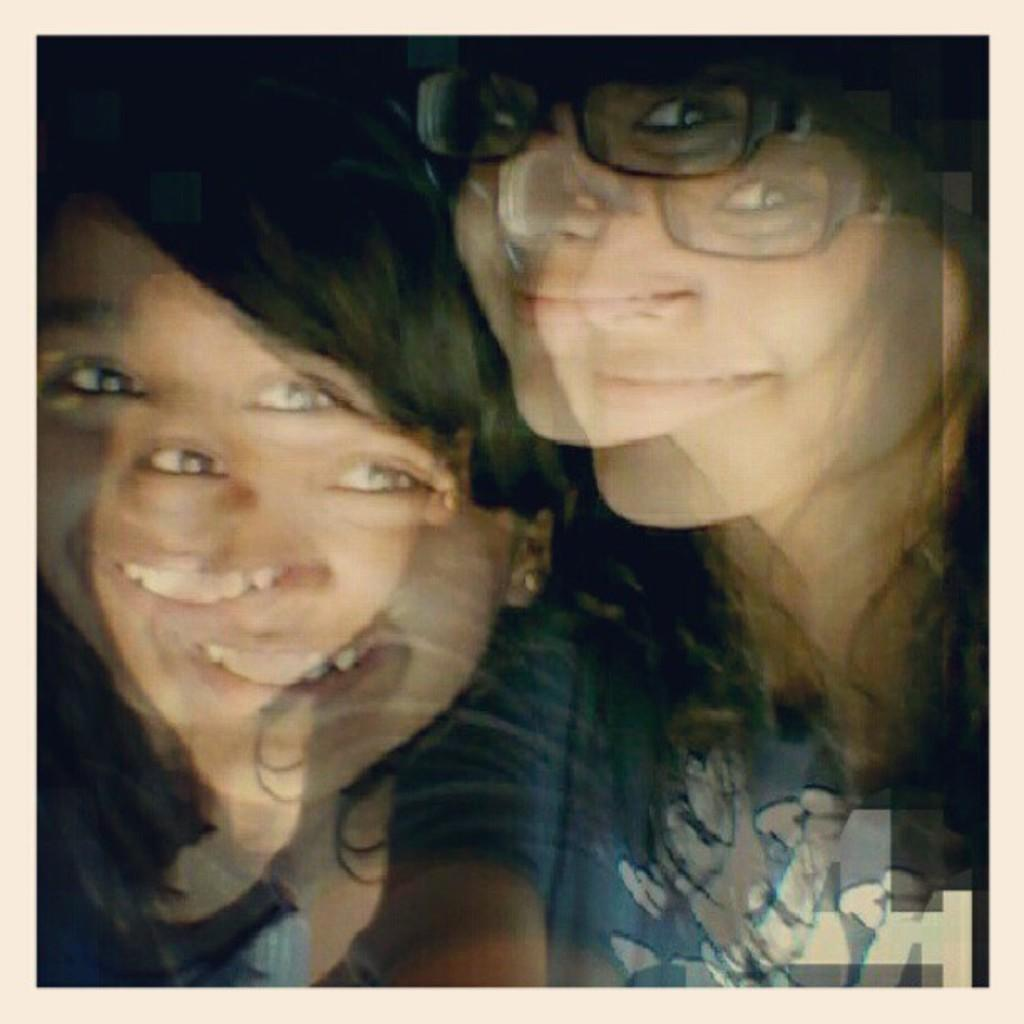How many people are in the image? There are two women in the image. What expressions do the women have? Both women are smiling. Can you describe any accessories worn by the women? One of the women is wearing spectacles. What type of sofa can be seen in the background of the image? There is no sofa present in the image; it only features two women. How many bikes are visible in the image? There are no bikes visible in the image. 